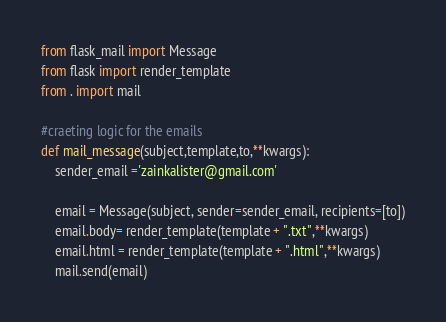<code> <loc_0><loc_0><loc_500><loc_500><_Python_>
from flask_mail import Message
from flask import render_template
from . import mail

#craeting logic for the emails
def mail_message(subject,template,to,**kwargs):
    sender_email ='zainkalister@gmail.com'

    email = Message(subject, sender=sender_email, recipients=[to])
    email.body= render_template(template + ".txt",**kwargs)
    email.html = render_template(template + ".html",**kwargs)
    mail.send(email)
</code> 